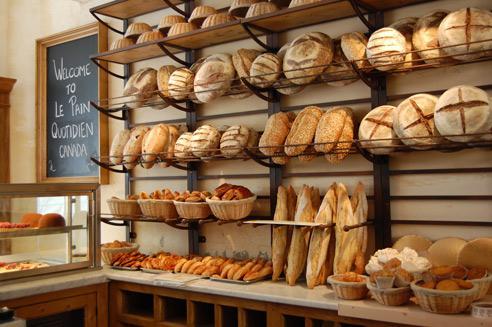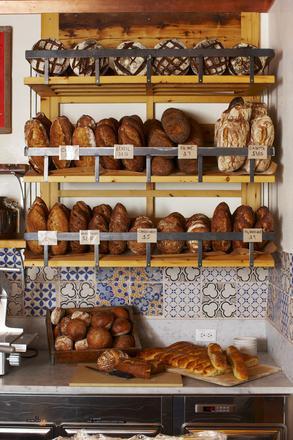The first image is the image on the left, the second image is the image on the right. Given the left and right images, does the statement "An image includes a bakery worker wearing a hat." hold true? Answer yes or no. No. The first image is the image on the left, the second image is the image on the right. Assess this claim about the two images: "At least one bakery worker is shown in at least one image.". Correct or not? Answer yes or no. No. 